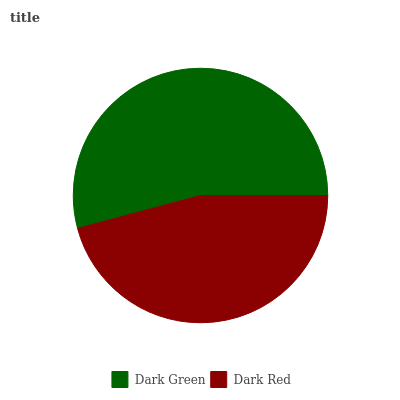Is Dark Red the minimum?
Answer yes or no. Yes. Is Dark Green the maximum?
Answer yes or no. Yes. Is Dark Red the maximum?
Answer yes or no. No. Is Dark Green greater than Dark Red?
Answer yes or no. Yes. Is Dark Red less than Dark Green?
Answer yes or no. Yes. Is Dark Red greater than Dark Green?
Answer yes or no. No. Is Dark Green less than Dark Red?
Answer yes or no. No. Is Dark Green the high median?
Answer yes or no. Yes. Is Dark Red the low median?
Answer yes or no. Yes. Is Dark Red the high median?
Answer yes or no. No. Is Dark Green the low median?
Answer yes or no. No. 